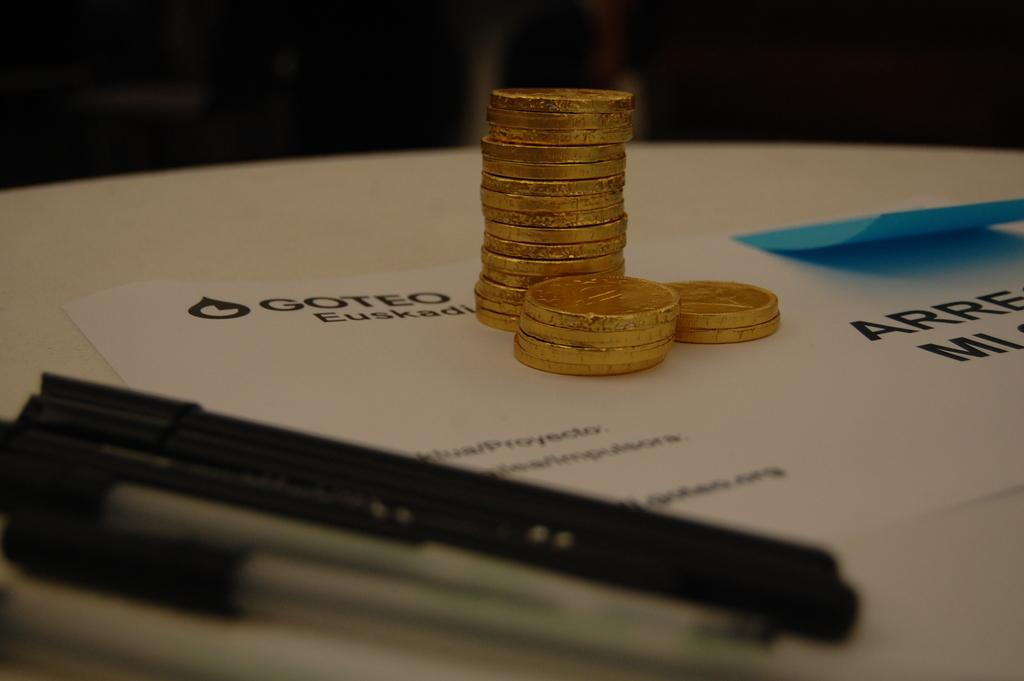<image>
Write a terse but informative summary of the picture. A stack of candy coins in gold foil is stacked on top of a piece of paper with Goteo in the upper left corner. 